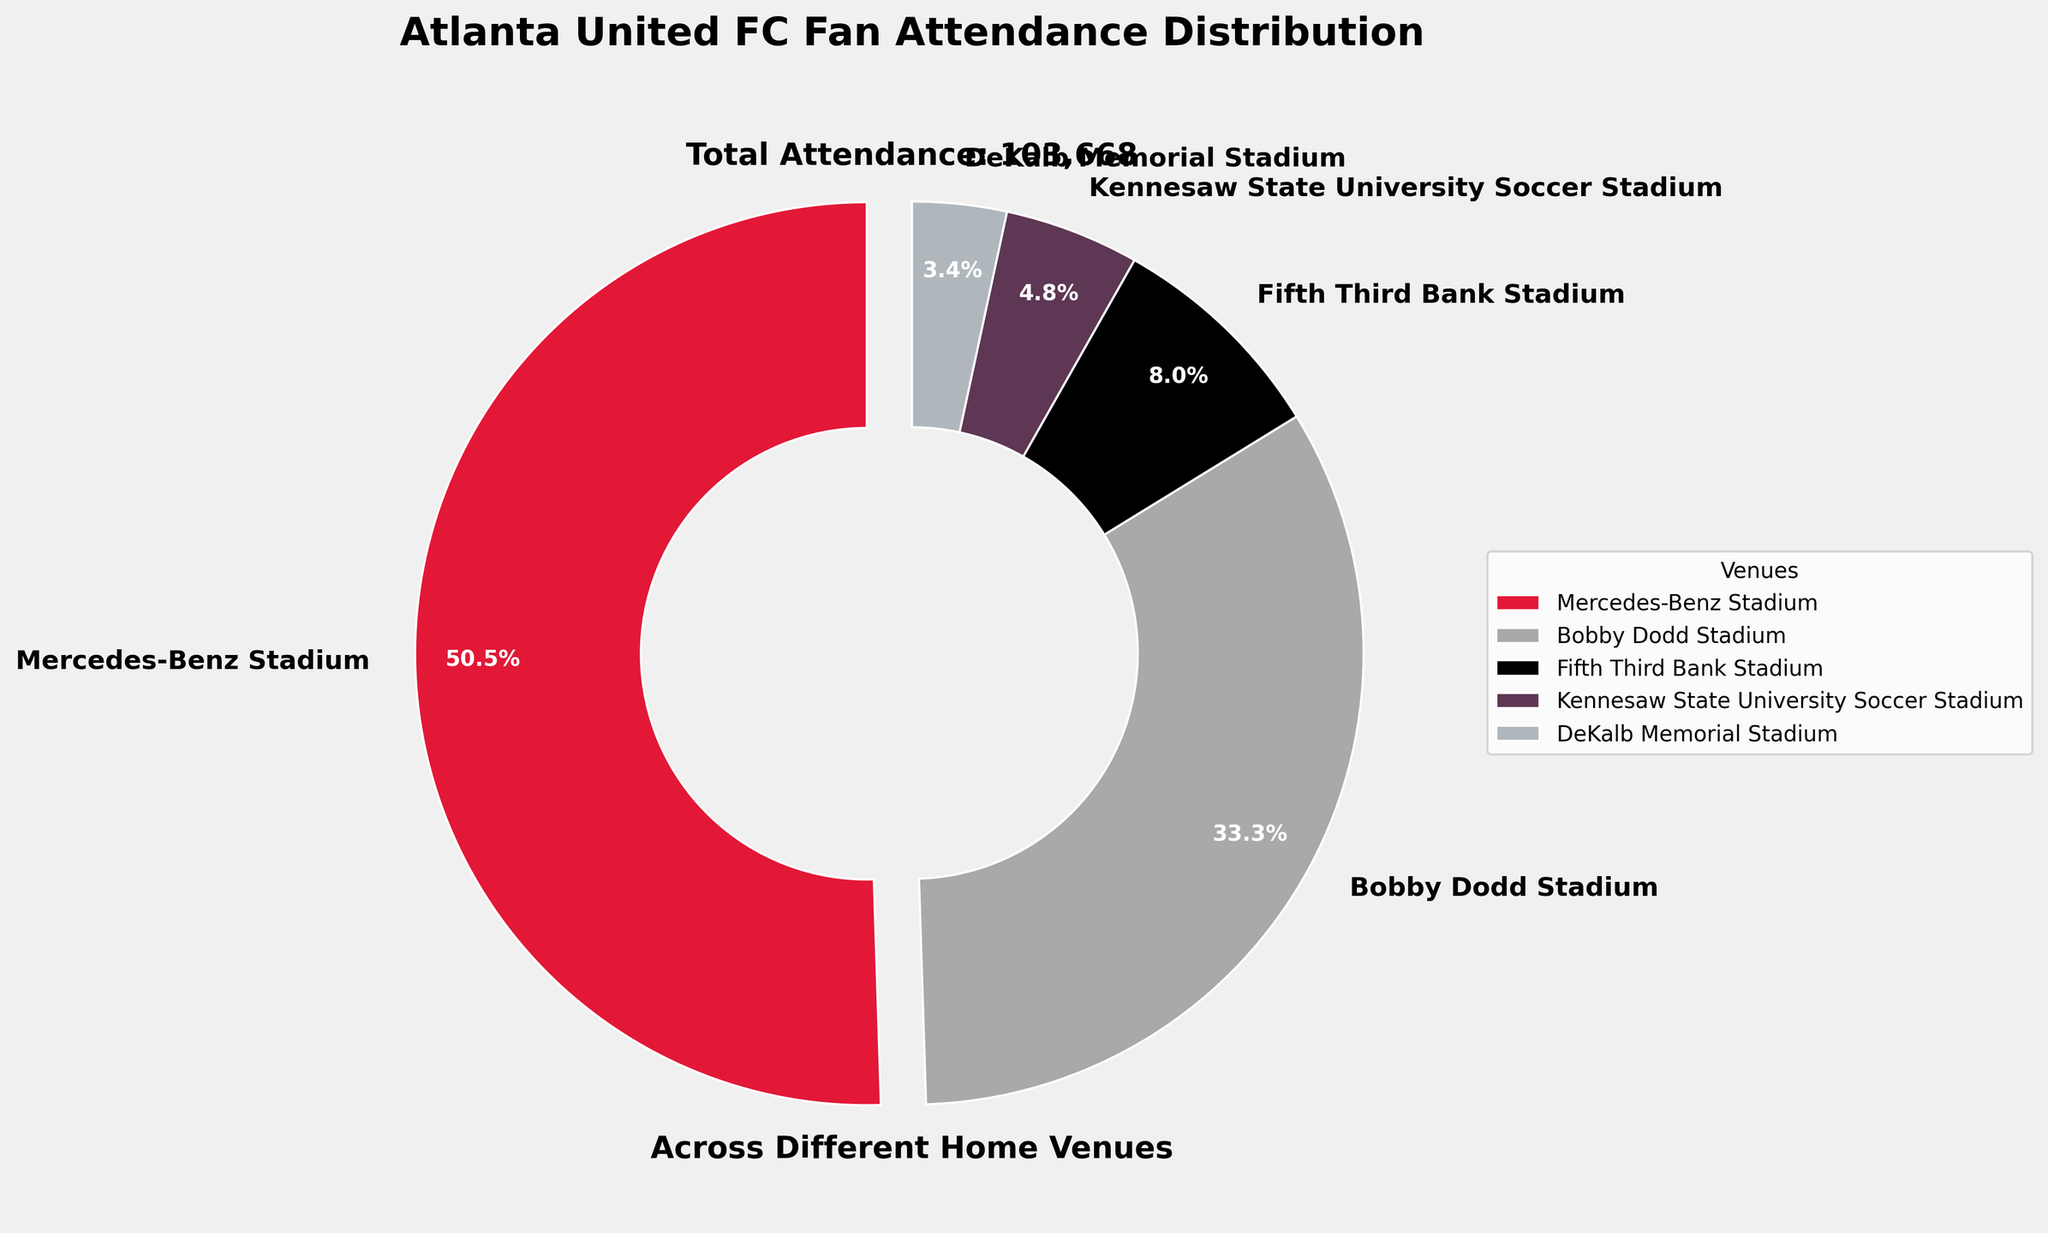what is the title of the figure? The title is positioned at the top of the figure. It reads "Atlanta United FC Fan Attendance Distribution".
Answer: Atlanta United FC Fan Attendance Distribution Which venue has the highest fan attendance percentage? By looking at the pie chart, the slice with the largest size represents the highest fan attendance. This slice is labeled "Mercedes-Benz Stadium".
Answer: Mercedes-Benz Stadium What percentage of the total attendance is from Bobby Dodd Stadium? The percentage is displayed directly on the slice representing Bobby Dodd Stadium in the pie chart.
Answer: 25.8% If we combine the attendance of Fifth Third Bank Stadium and DeKalb Memorial Stadium, what percentage of the total do they represent? The percentages for Fifth Third Bank Stadium and DeKalb Memorial Stadium are shown on their respective slices. Adding them together: 6.2% + 2.6% = 8.8%.
Answer: 8.8% What's the total attendance across all venues? The total attendance is mentioned below the pie chart. It reads "Total Attendance: 103,668".
Answer: 103,668 How does the attendance at Kennesaw State University Soccer Stadium compare with DeKalb Memorial Stadium? Comparing the labels on the pie chart slices, Kennesaw State University Soccer Stadium has a larger slice than DeKalb Memorial Stadium.
Answer: Kennesaw State University Soccer Stadium has higher attendance What color represents Fifth Third Bank Stadium? The color is clearly visible in the pie chart. Fifth Third Bank Stadium is represented by black.
Answer: Black Which venue’s attendance slice is the smallest? By visually inspecting the pie chart, the slice with the smallest size is labeled "DeKalb Memorial Stadium".
Answer: DeKalb Memorial Stadium What's the attendance at Bobby Dodd Stadium relative to Mercedes-Benz Stadium's attendance? Bobby Dodd Stadium's attendance is 34,500, and Mercedes-Benz Stadium's attendance is 52,350. The ratio can be given by dividing the two numbers: 34,500 / 52,350 ≈ 0.66.
Answer: Approximately 0.66 Is there a venue with an attendance percentage lower than 5%? The pie chart shows that DeKalb Memorial Stadium has an attendance percentage of 3.4%, which is less than 5%.
Answer: Yes, DeKalb Memorial Stadium 